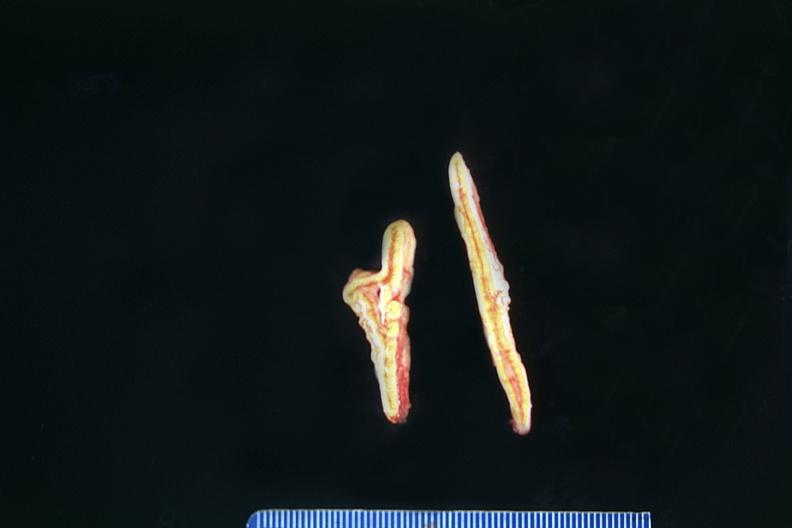what is present?
Answer the question using a single word or phrase. Endocrine 